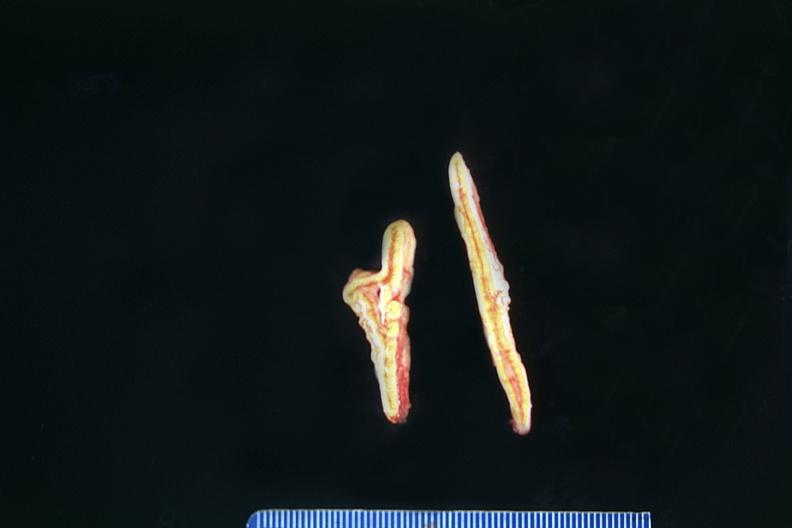what is present?
Answer the question using a single word or phrase. Endocrine 